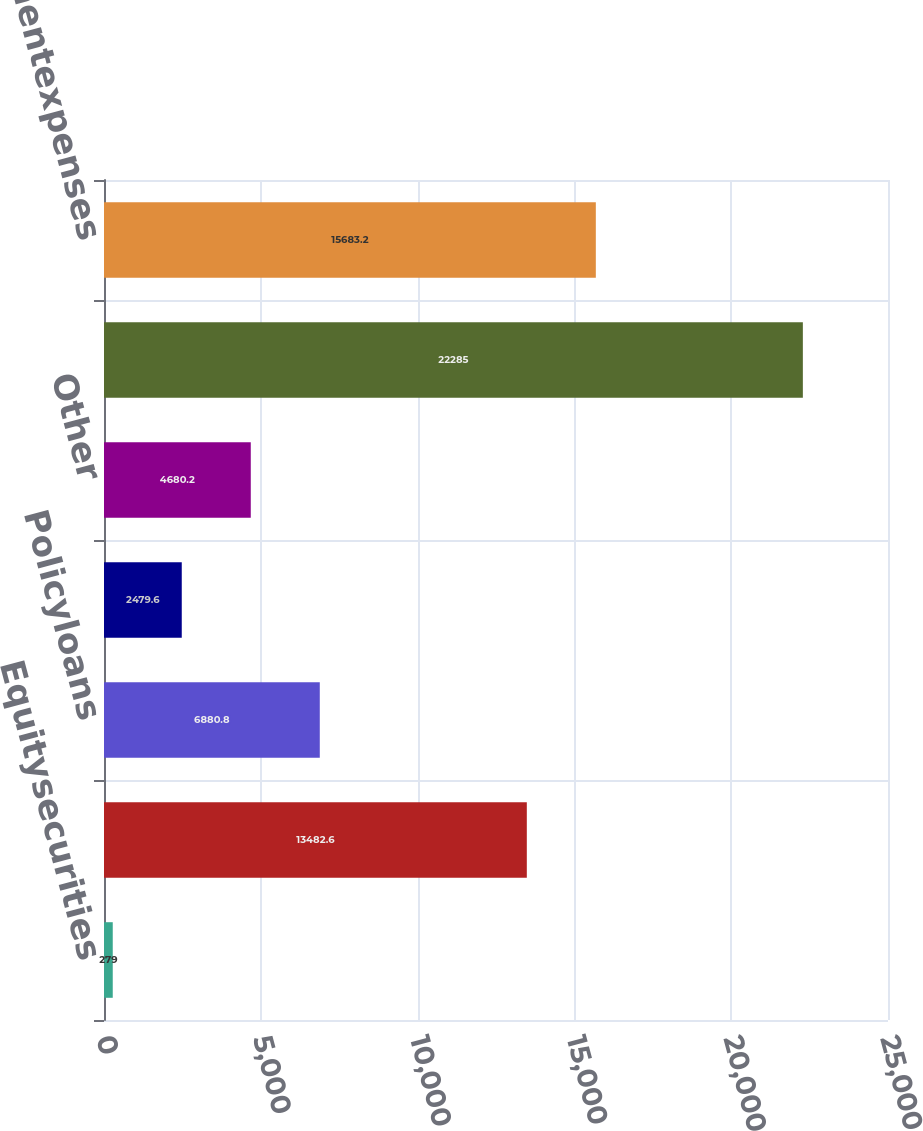Convert chart to OTSL. <chart><loc_0><loc_0><loc_500><loc_500><bar_chart><fcel>Equitysecurities<fcel>Mortgageandconsumerloans<fcel>Policyloans<fcel>Unnamed: 3<fcel>Other<fcel>Totalinvestmentincome<fcel>LessInvestmentexpenses<nl><fcel>279<fcel>13482.6<fcel>6880.8<fcel>2479.6<fcel>4680.2<fcel>22285<fcel>15683.2<nl></chart> 